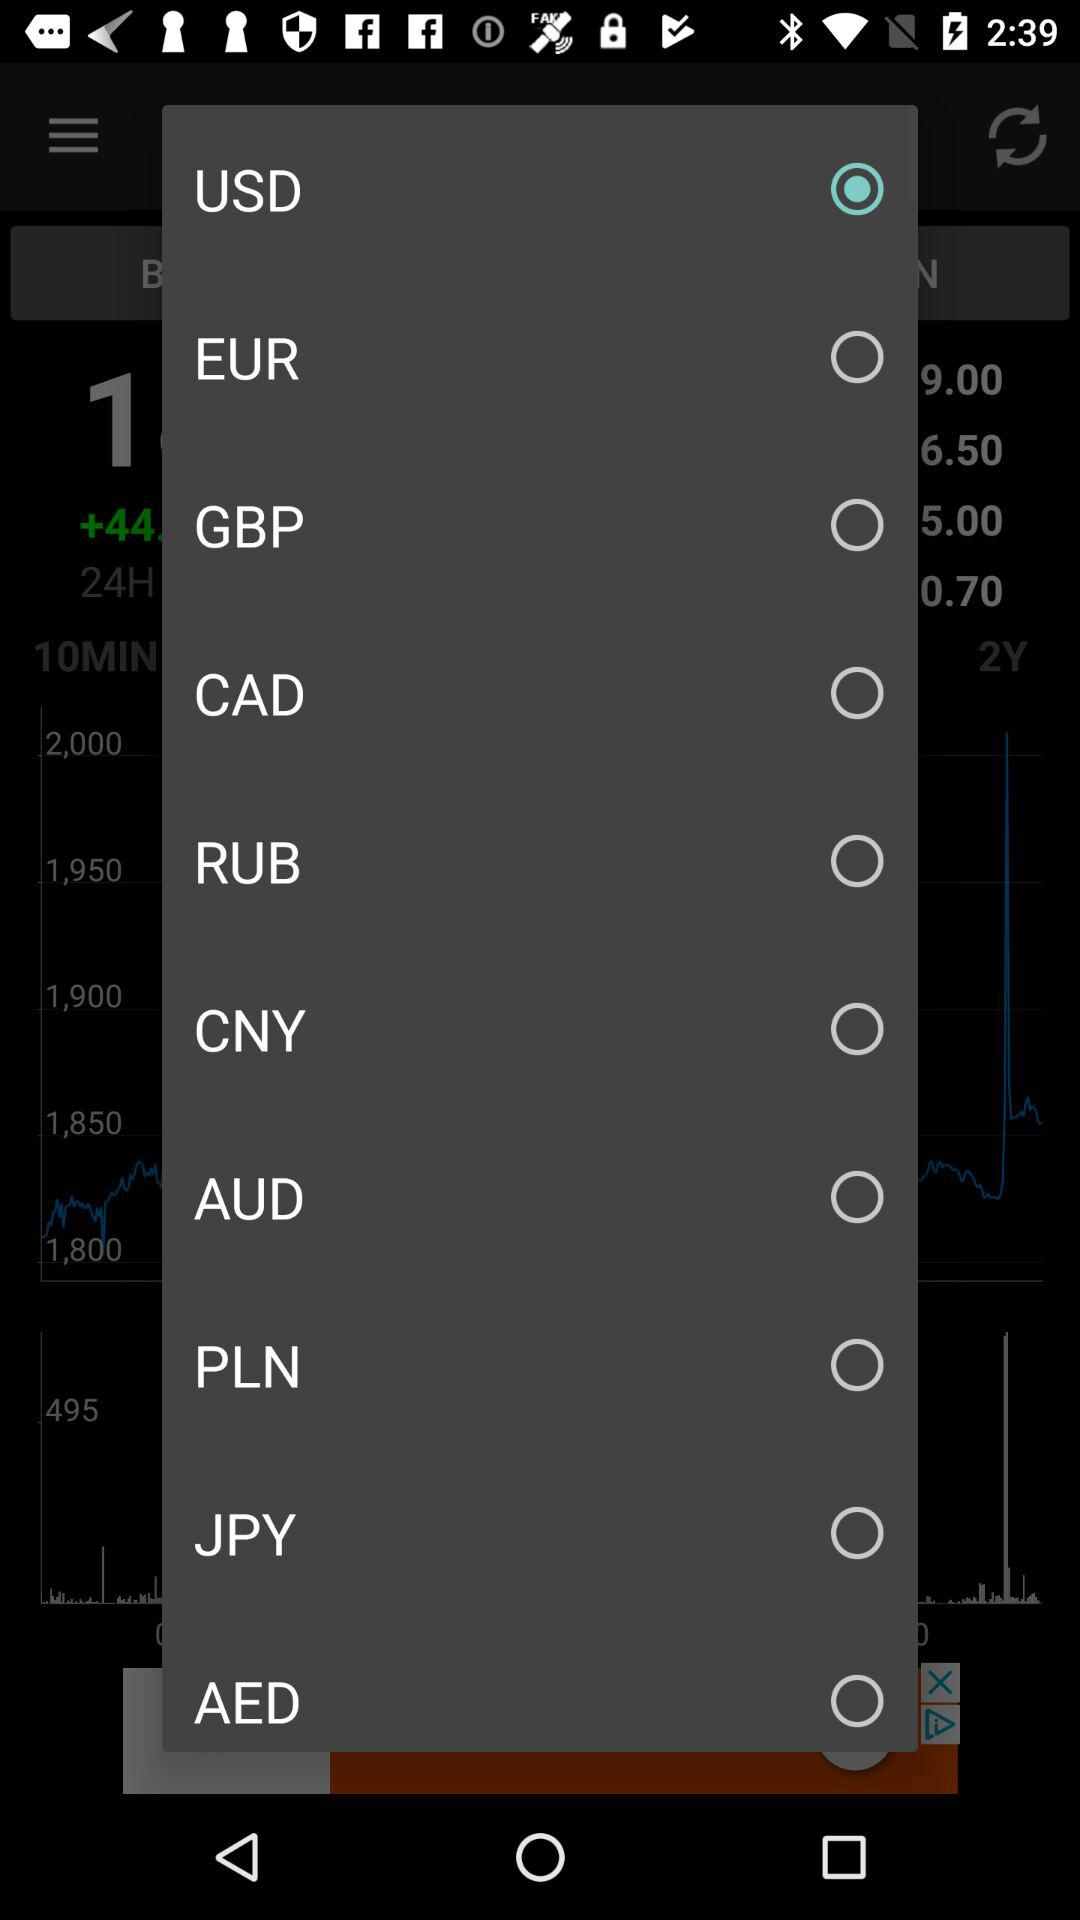How many currencies are available for selection?
Answer the question using a single word or phrase. 10 